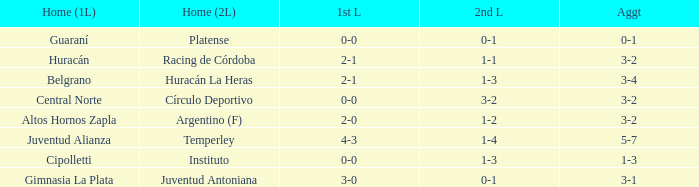Which team had a 1-1 tie in the 2nd leg at home and achieved a 3-2 overall score? Racing de Córdoba. 